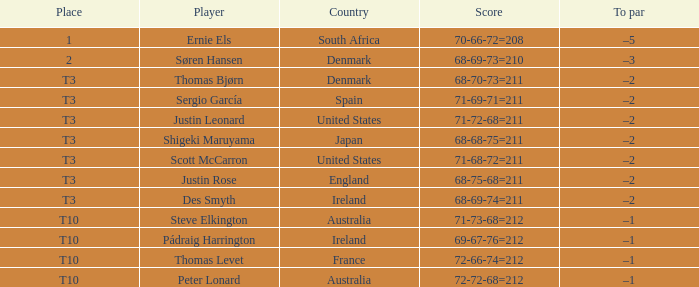What was Australia's score when Peter Lonard played? 72-72-68=212. 